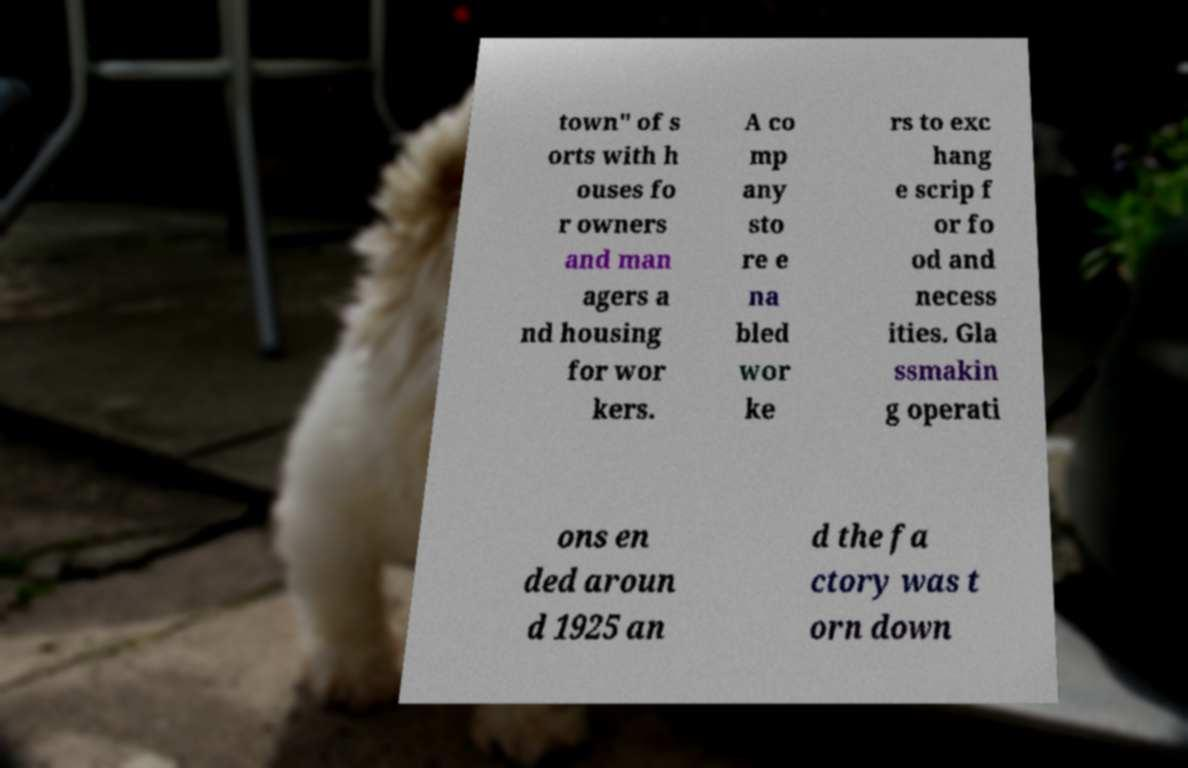For documentation purposes, I need the text within this image transcribed. Could you provide that? town" of s orts with h ouses fo r owners and man agers a nd housing for wor kers. A co mp any sto re e na bled wor ke rs to exc hang e scrip f or fo od and necess ities. Gla ssmakin g operati ons en ded aroun d 1925 an d the fa ctory was t orn down 